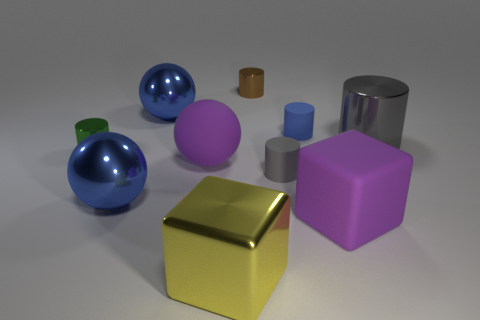How many small objects have the same color as the large metallic cylinder? In the image, there are a variety of objects with different colors and sizes. Focusing on the large metallic cylinder, which is silver in color, there is one small object—a smaller cylinder—that shares the same silver hue. 